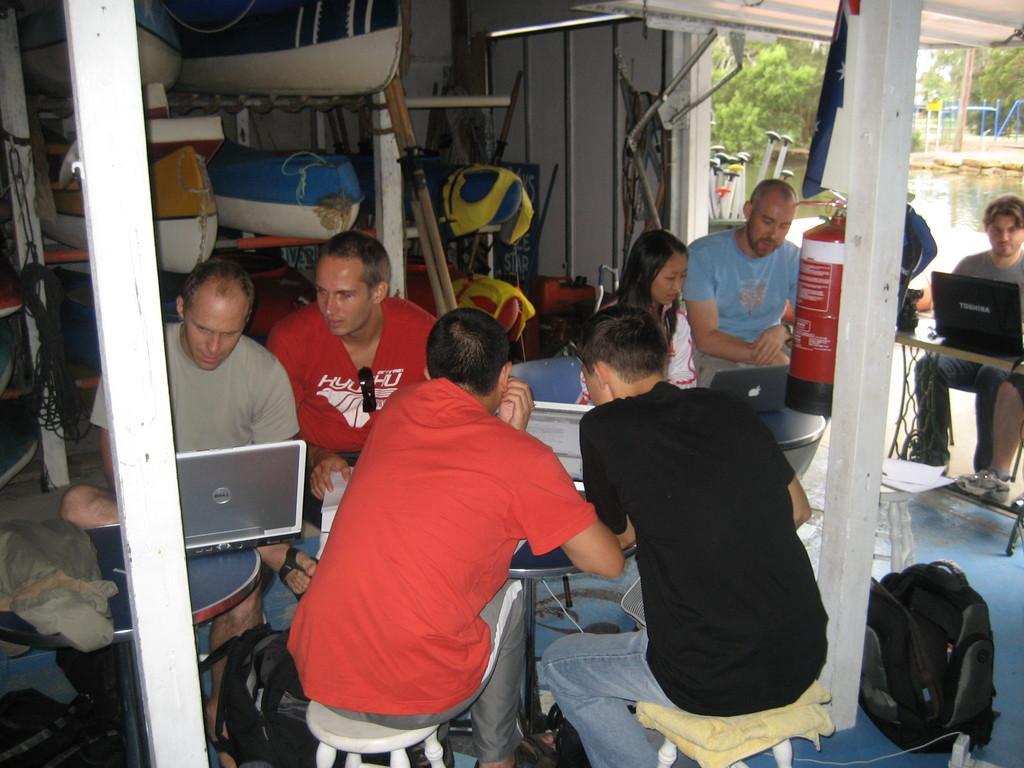Could you give a brief overview of what you see in this image? In this image we can see few people sitting on the chairs near tables and holding a laptops. This is a fire extinguisher. In the background we can see boats, water and trees. 